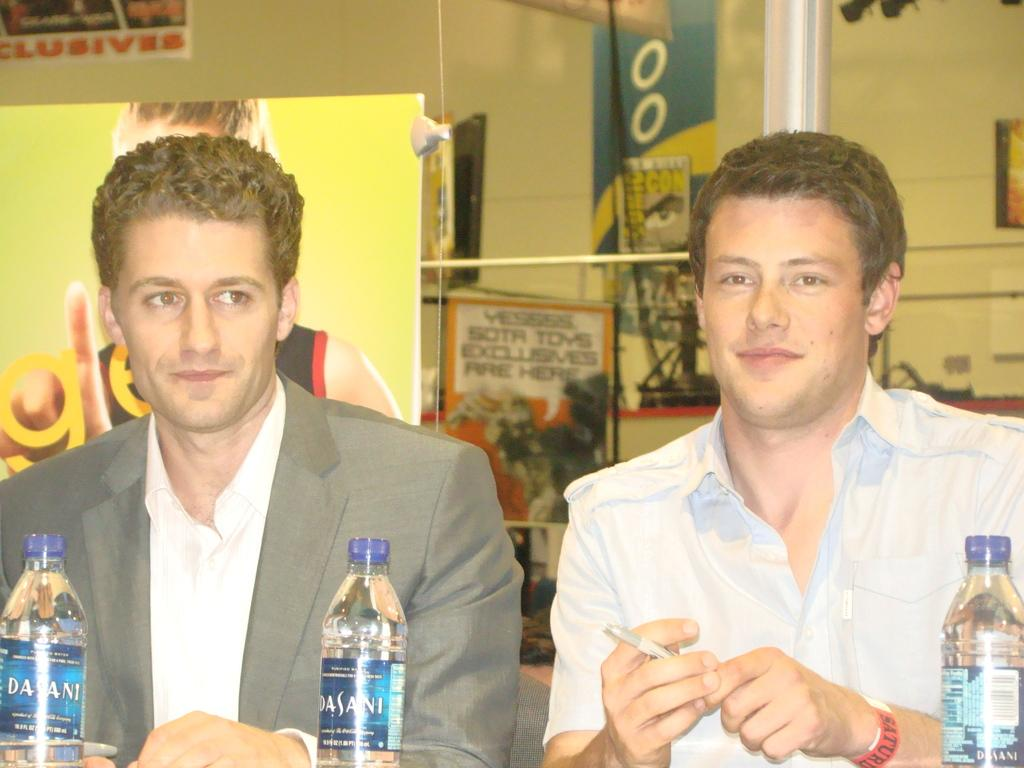How many people are present in the image? There are two people in the image. What objects are in front of the people? There are bottles in front of the people. What can be seen on the wall in the background of the image? There are boards attached to the wall in the background of the image. What is the distance between the oven and the test in the image? There is no oven or test present in the image. 